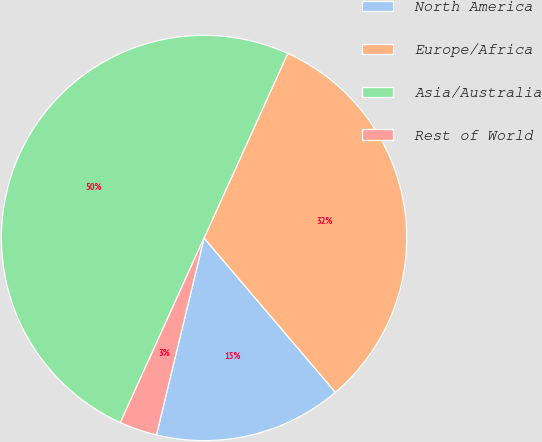<chart> <loc_0><loc_0><loc_500><loc_500><pie_chart><fcel>North America<fcel>Europe/Africa<fcel>Asia/Australia<fcel>Rest of World<nl><fcel>15.0%<fcel>32.0%<fcel>50.0%<fcel>3.0%<nl></chart> 